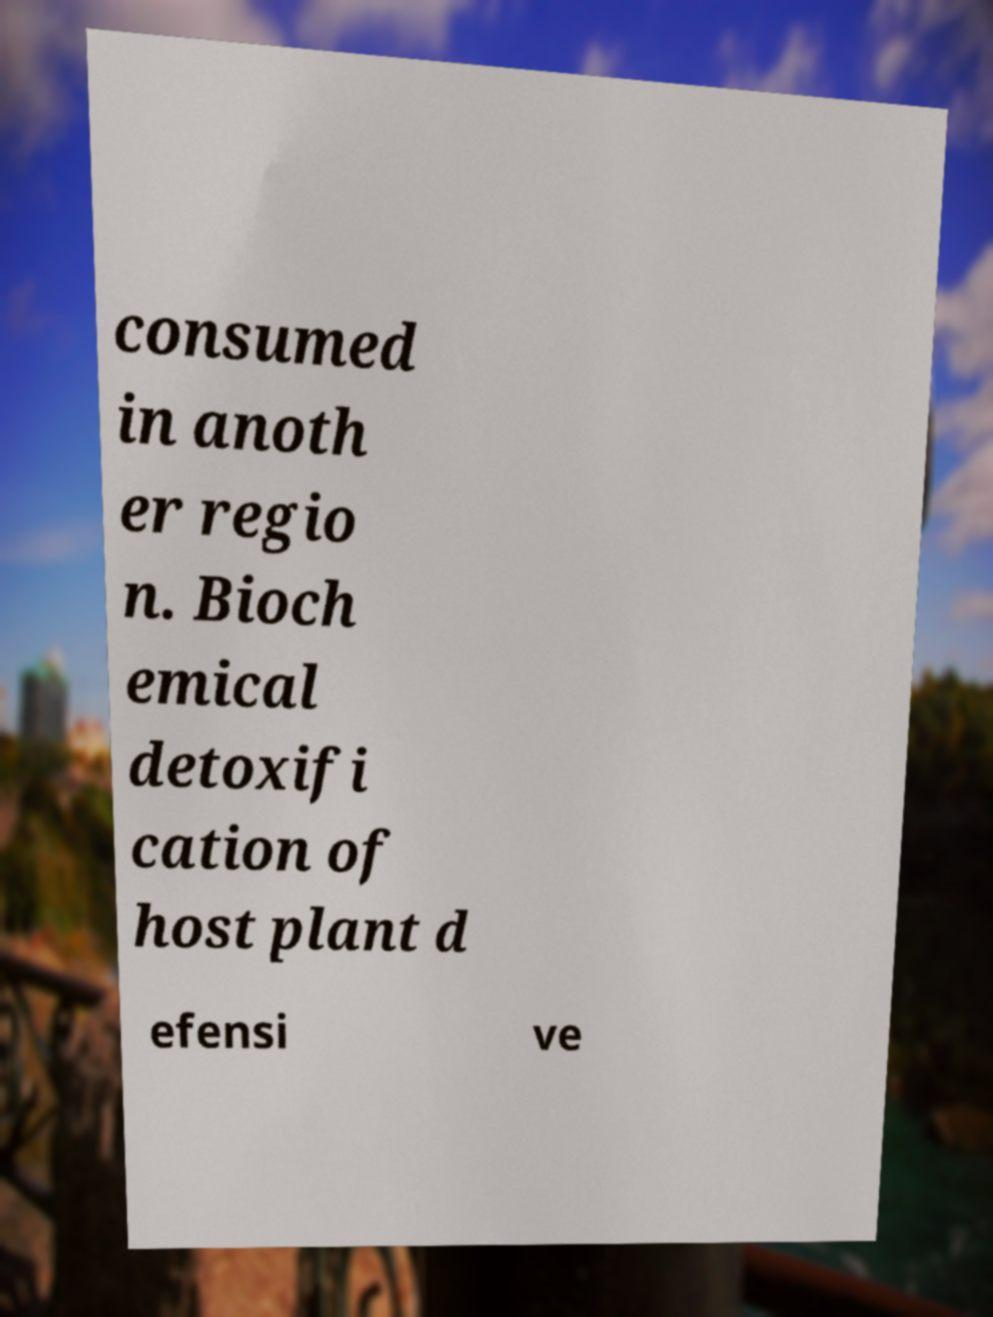For documentation purposes, I need the text within this image transcribed. Could you provide that? consumed in anoth er regio n. Bioch emical detoxifi cation of host plant d efensi ve 